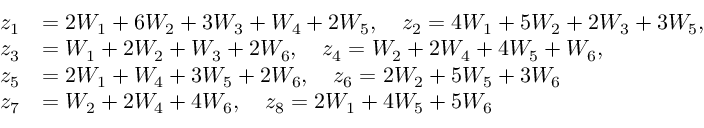Convert formula to latex. <formula><loc_0><loc_0><loc_500><loc_500>\begin{array} { r l } { z _ { 1 } } & { = 2 W _ { 1 } + 6 W _ { 2 } + 3 W _ { 3 } + W _ { 4 } + 2 W _ { 5 } , \quad z _ { 2 } = 4 W _ { 1 } + 5 W _ { 2 } + 2 W _ { 3 } + 3 W _ { 5 } , } \\ { z _ { 3 } } & { = W _ { 1 } + 2 W _ { 2 } + W _ { 3 } + 2 W _ { 6 } , \quad z _ { 4 } = W _ { 2 } + 2 W _ { 4 } + 4 W _ { 5 } + W _ { 6 } , } \\ { z _ { 5 } } & { = 2 W _ { 1 } + W _ { 4 } + 3 W _ { 5 } + 2 W _ { 6 } , \quad z _ { 6 } = 2 W _ { 2 } + 5 W _ { 5 } + 3 W _ { 6 } } \\ { z _ { 7 } } & { = W _ { 2 } + 2 W _ { 4 } + 4 W _ { 6 } , \quad z _ { 8 } = 2 W _ { 1 } + 4 W _ { 5 } + 5 W _ { 6 } } \end{array}</formula> 